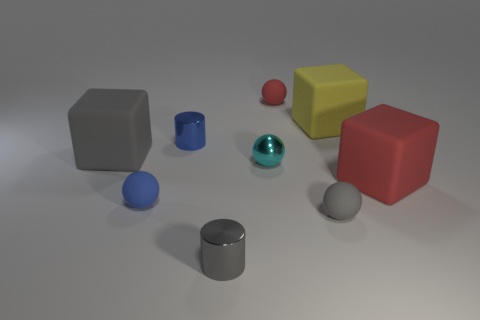Subtract all large yellow rubber blocks. How many blocks are left? 2 Add 1 gray cubes. How many objects exist? 10 Subtract all cubes. How many objects are left? 6 Subtract all gray balls. How many balls are left? 3 Subtract 2 cylinders. How many cylinders are left? 0 Subtract all blue cylinders. Subtract all blue balls. How many cylinders are left? 1 Subtract all gray cubes. How many brown spheres are left? 0 Subtract all purple spheres. Subtract all metal spheres. How many objects are left? 8 Add 7 red rubber objects. How many red rubber objects are left? 9 Add 7 red rubber balls. How many red rubber balls exist? 8 